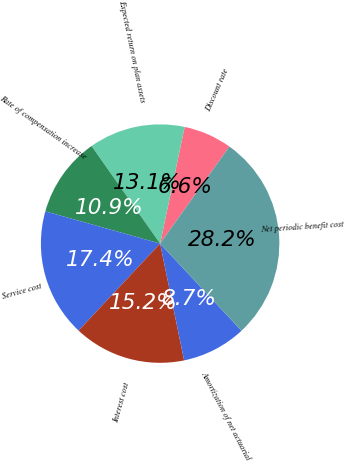Convert chart to OTSL. <chart><loc_0><loc_0><loc_500><loc_500><pie_chart><fcel>Discount rate<fcel>Expected return on plan assets<fcel>Rate of compensation increase<fcel>Service cost<fcel>Interest cost<fcel>Amortization of net actuarial<fcel>Net periodic benefit cost<nl><fcel>6.57%<fcel>13.05%<fcel>10.89%<fcel>17.37%<fcel>15.21%<fcel>8.73%<fcel>28.17%<nl></chart> 